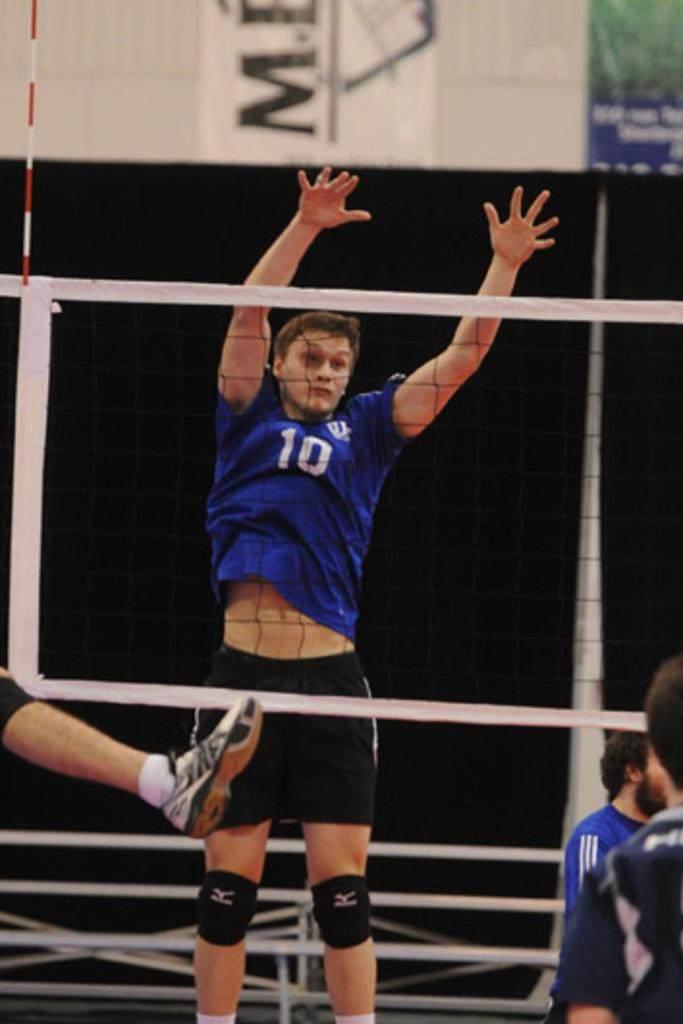Provide a one-sentence caption for the provided image. Some men are playing volley ball and a player in a blue shirt with the number 10 on it is jumping. 